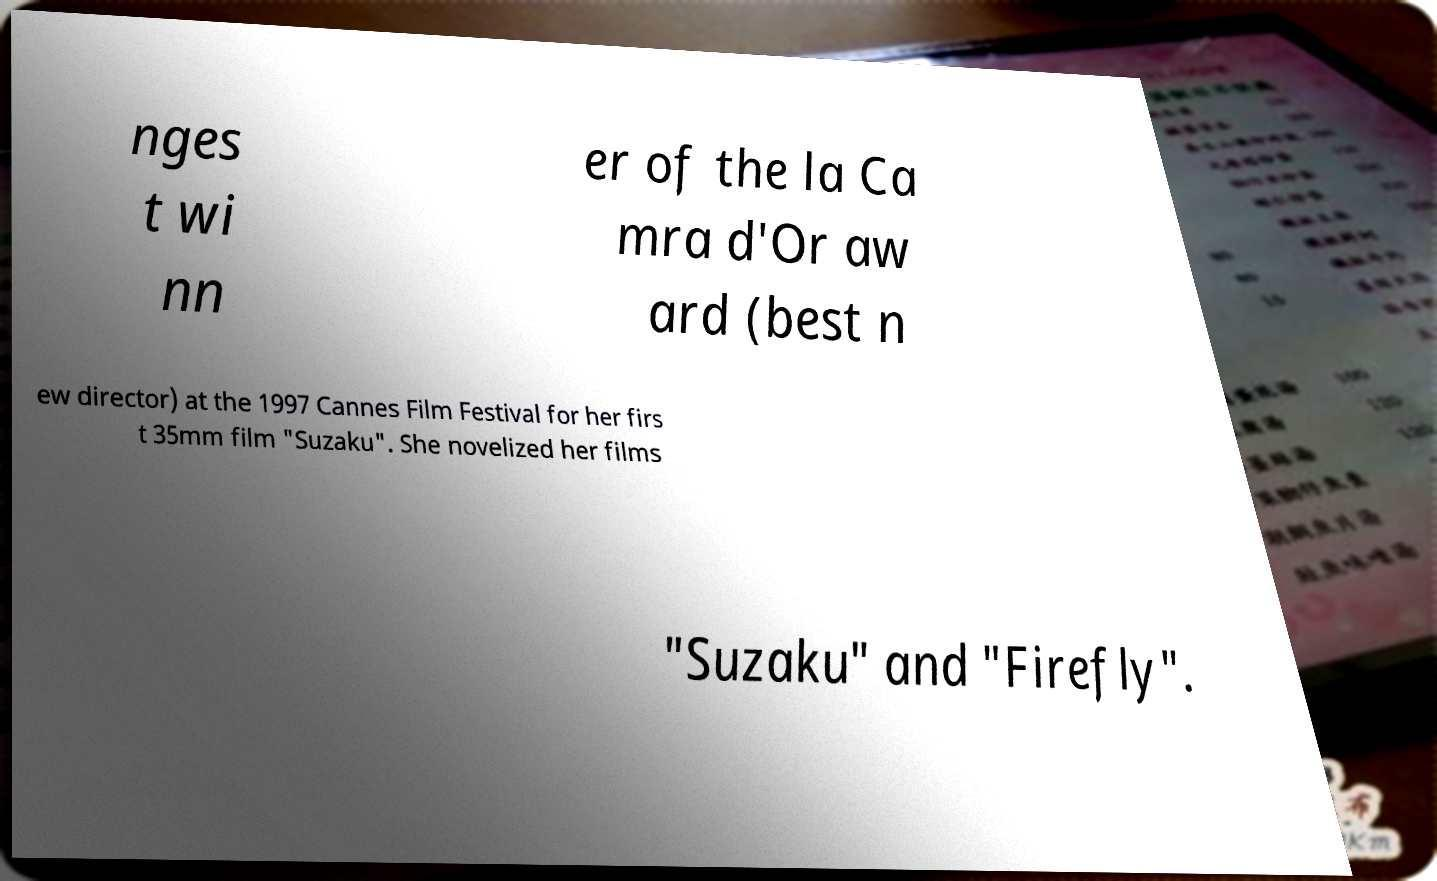Can you read and provide the text displayed in the image?This photo seems to have some interesting text. Can you extract and type it out for me? nges t wi nn er of the la Ca mra d'Or aw ard (best n ew director) at the 1997 Cannes Film Festival for her firs t 35mm film "Suzaku". She novelized her films "Suzaku" and "Firefly". 